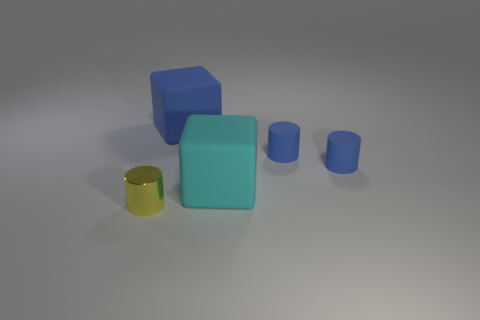Are there any shadows in the image indicating the light source? Yes, there are shadows in the image that extend to the right from the objects, suggesting that the light source is to the left of the scene. 